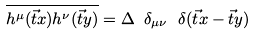Convert formula to latex. <formula><loc_0><loc_0><loc_500><loc_500>\overline { h ^ { \mu } ( \vec { t } x ) h ^ { \nu } ( \vec { t } y ) } = \Delta \ \delta _ { \mu \nu } \ \delta ( \vec { t } x - \vec { t } y )</formula> 